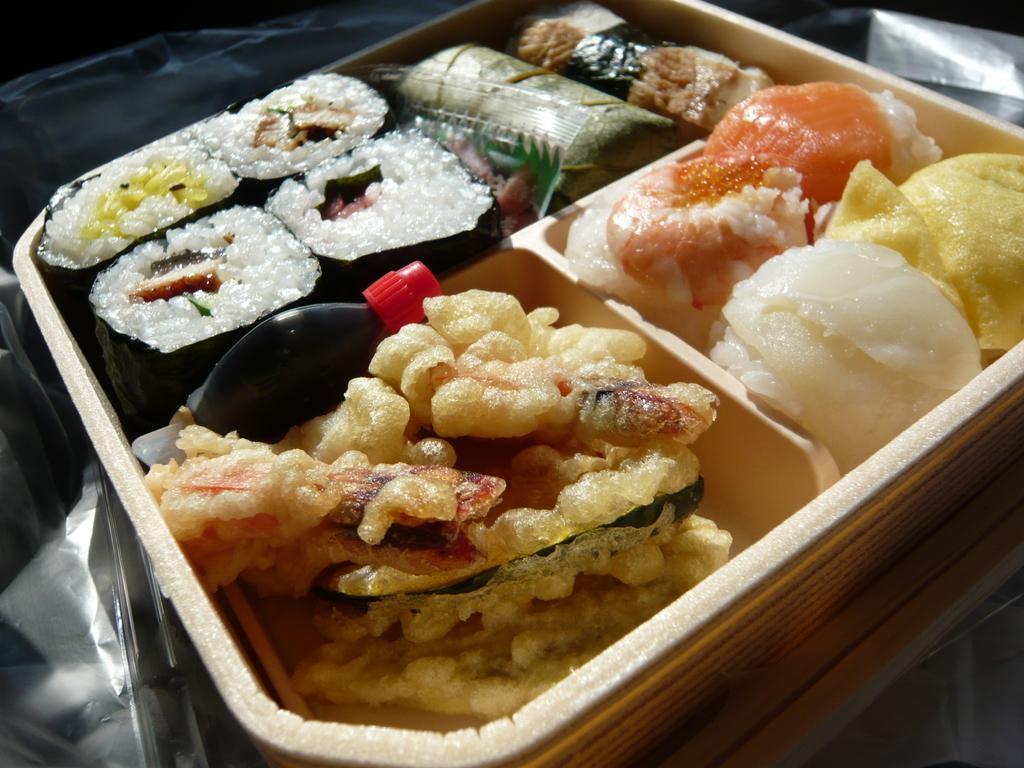Could you give a brief overview of what you see in this image? In this image, we can see some food item on a plate is placed on the surface. We can also see some cover. 